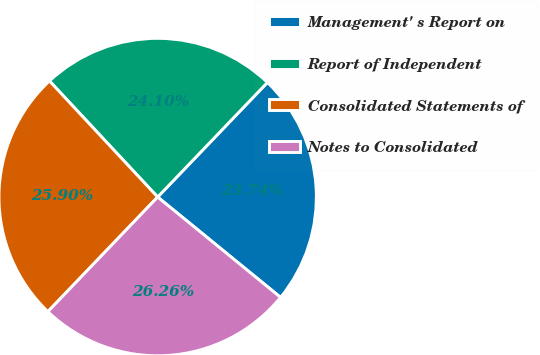Convert chart to OTSL. <chart><loc_0><loc_0><loc_500><loc_500><pie_chart><fcel>Management' s Report on<fcel>Report of Independent<fcel>Consolidated Statements of<fcel>Notes to Consolidated<nl><fcel>23.74%<fcel>24.1%<fcel>25.9%<fcel>26.26%<nl></chart> 